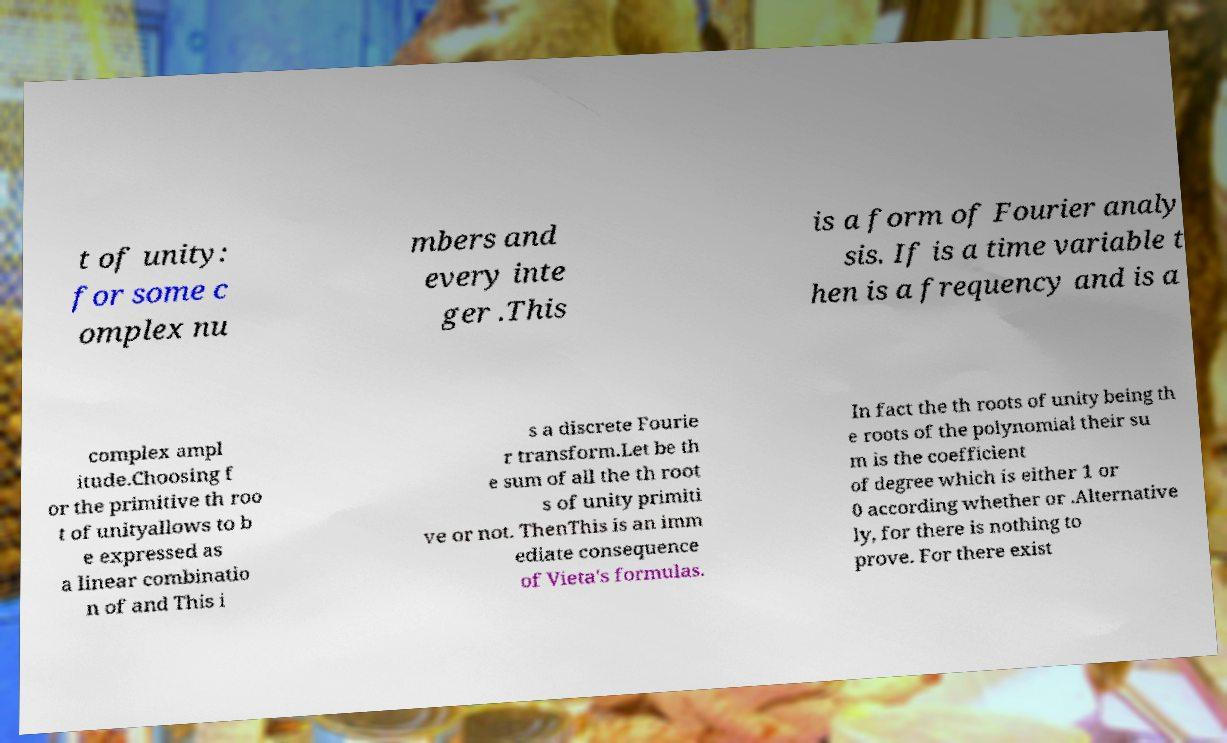Please identify and transcribe the text found in this image. t of unity: for some c omplex nu mbers and every inte ger .This is a form of Fourier analy sis. If is a time variable t hen is a frequency and is a complex ampl itude.Choosing f or the primitive th roo t of unityallows to b e expressed as a linear combinatio n of and This i s a discrete Fourie r transform.Let be th e sum of all the th root s of unity primiti ve or not. ThenThis is an imm ediate consequence of Vieta's formulas. In fact the th roots of unity being th e roots of the polynomial their su m is the coefficient of degree which is either 1 or 0 according whether or .Alternative ly, for there is nothing to prove. For there exist 